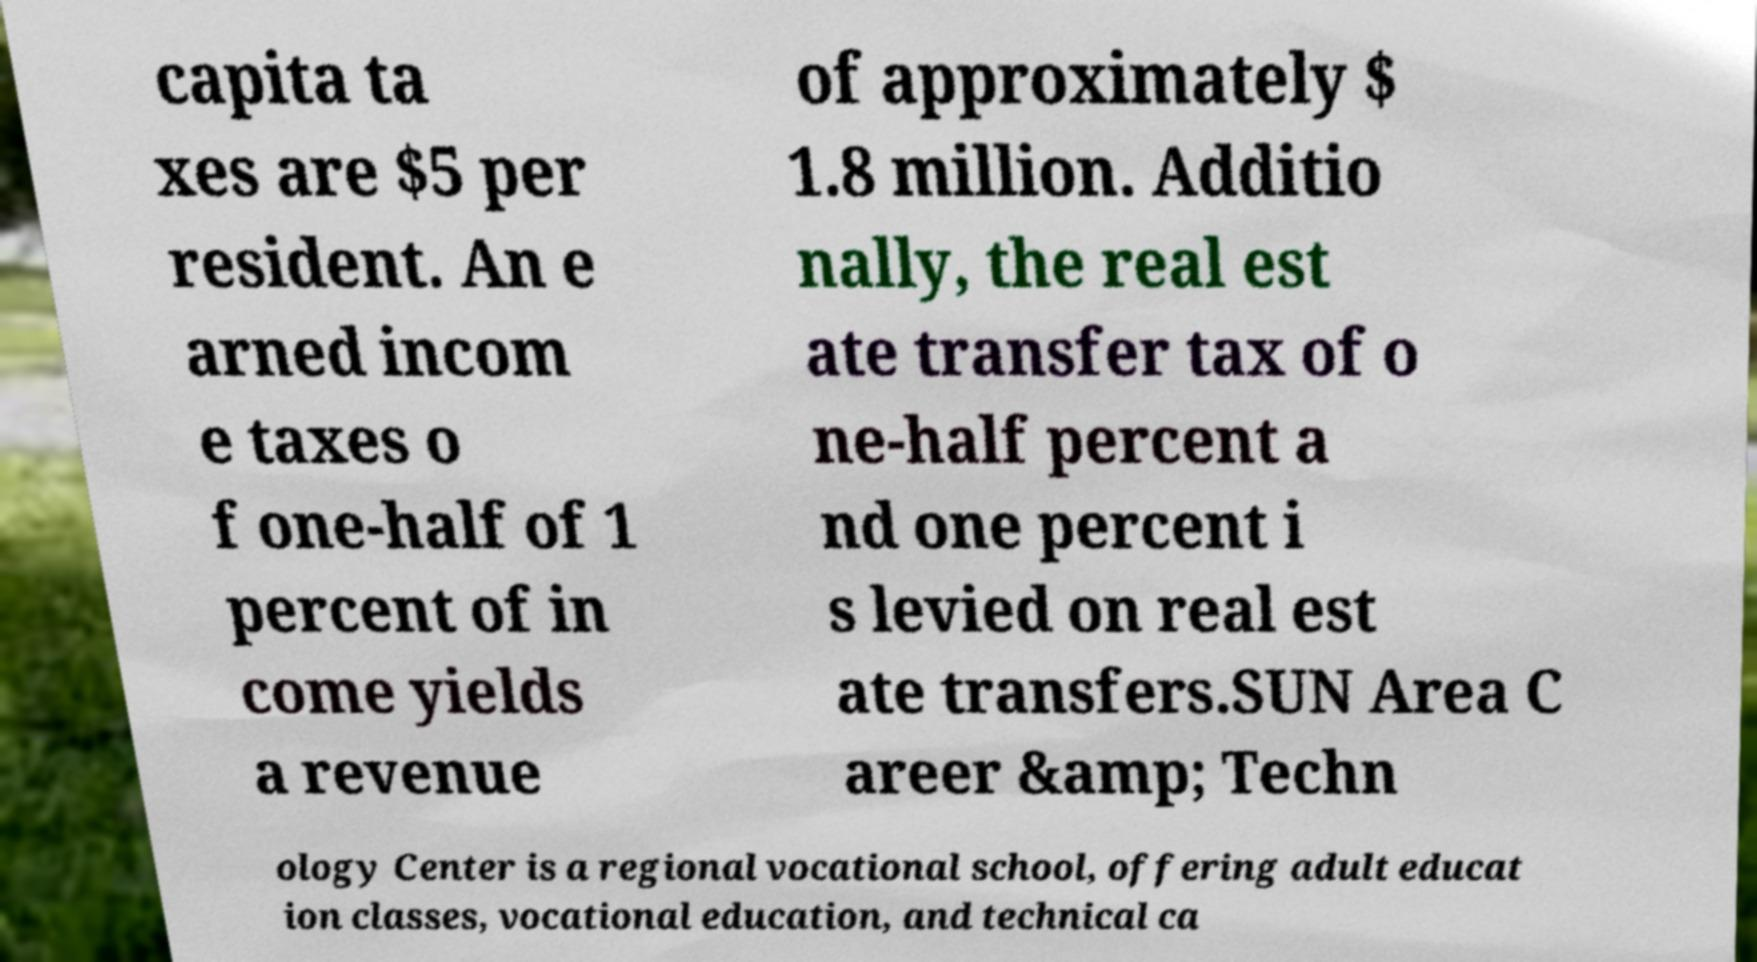Please read and relay the text visible in this image. What does it say? capita ta xes are $5 per resident. An e arned incom e taxes o f one-half of 1 percent of in come yields a revenue of approximately $ 1.8 million. Additio nally, the real est ate transfer tax of o ne-half percent a nd one percent i s levied on real est ate transfers.SUN Area C areer &amp; Techn ology Center is a regional vocational school, offering adult educat ion classes, vocational education, and technical ca 